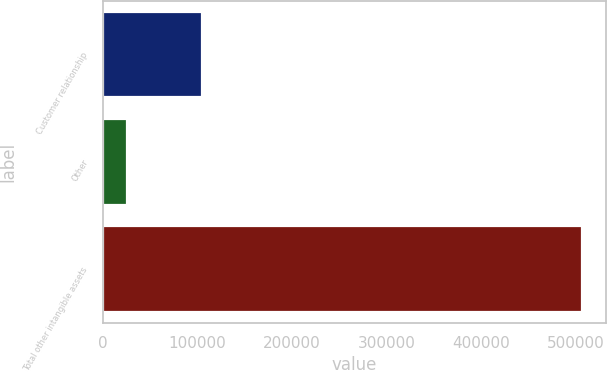Convert chart. <chart><loc_0><loc_0><loc_500><loc_500><bar_chart><fcel>Customer relationship<fcel>Other<fcel>Total other intangible assets<nl><fcel>104574<fcel>25164<fcel>506584<nl></chart> 